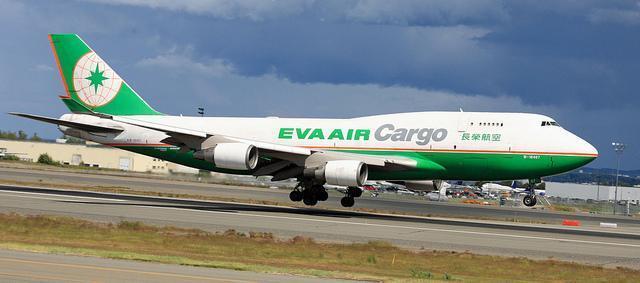How many people are in the college?
Give a very brief answer. 0. 